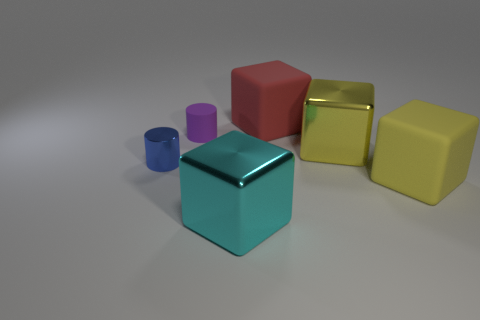Is the size of the metal block that is behind the big cyan metal cube the same as the block on the right side of the yellow metal cube?
Make the answer very short. Yes. The metallic object to the right of the large shiny block to the left of the yellow object behind the blue metal cylinder is what color?
Offer a terse response. Yellow. Are there any brown things of the same shape as the red rubber object?
Keep it short and to the point. No. Is the number of matte cylinders in front of the purple thing the same as the number of large cyan cubes on the left side of the big red matte cube?
Provide a succinct answer. No. There is a yellow object left of the large yellow rubber thing; does it have the same shape as the purple object?
Offer a very short reply. No. Does the cyan object have the same shape as the blue metallic thing?
Your response must be concise. No. How many rubber things are either small blue cylinders or large cyan cubes?
Offer a very short reply. 0. Do the yellow matte thing and the shiny cylinder have the same size?
Ensure brevity in your answer.  No. What number of things are either large yellow shiny cubes or metal objects behind the tiny blue metal object?
Keep it short and to the point. 1. There is a cylinder that is the same size as the purple matte object; what is its material?
Offer a terse response. Metal. 